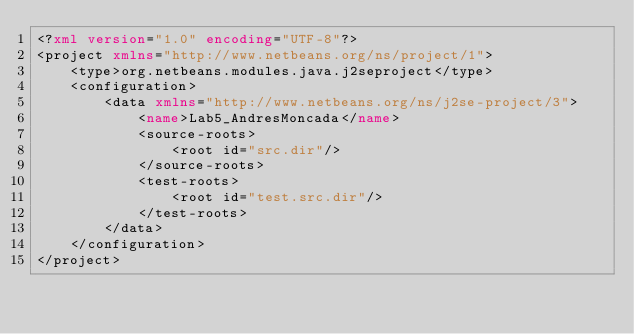Convert code to text. <code><loc_0><loc_0><loc_500><loc_500><_XML_><?xml version="1.0" encoding="UTF-8"?>
<project xmlns="http://www.netbeans.org/ns/project/1">
    <type>org.netbeans.modules.java.j2seproject</type>
    <configuration>
        <data xmlns="http://www.netbeans.org/ns/j2se-project/3">
            <name>Lab5_AndresMoncada</name>
            <source-roots>
                <root id="src.dir"/>
            </source-roots>
            <test-roots>
                <root id="test.src.dir"/>
            </test-roots>
        </data>
    </configuration>
</project>
</code> 